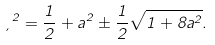<formula> <loc_0><loc_0><loc_500><loc_500>\xi ^ { 2 } = \frac { 1 } { 2 } + a ^ { 2 } \pm \frac { 1 } { 2 } \sqrt { 1 + 8 a ^ { 2 } } .</formula> 